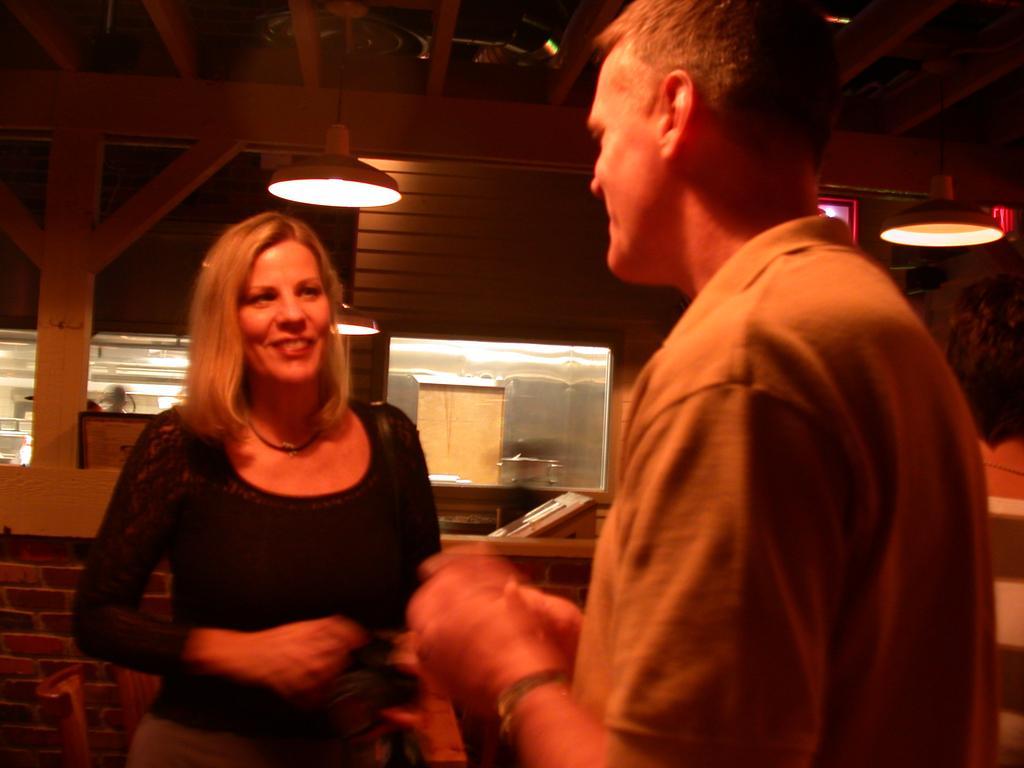Could you give a brief overview of what you see in this image? This picture is taken inside the room. In this image, we can see two people man and woman. In the background, we can see a glass window. At the top, we can see a roof with few lights. 